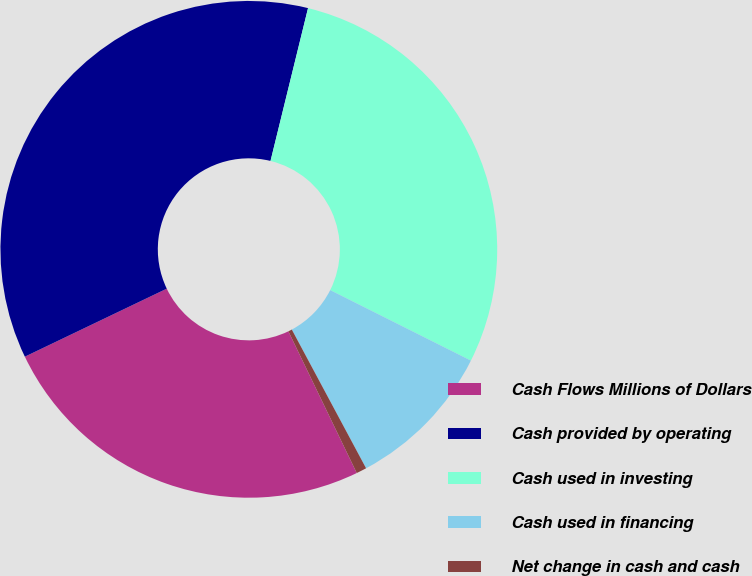<chart> <loc_0><loc_0><loc_500><loc_500><pie_chart><fcel>Cash Flows Millions of Dollars<fcel>Cash provided by operating<fcel>Cash used in investing<fcel>Cash used in financing<fcel>Net change in cash and cash<nl><fcel>25.04%<fcel>35.94%<fcel>28.56%<fcel>9.78%<fcel>0.67%<nl></chart> 